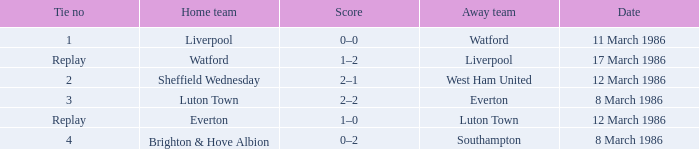What was the tie resulting from Sheffield Wednesday's game? 2.0. 